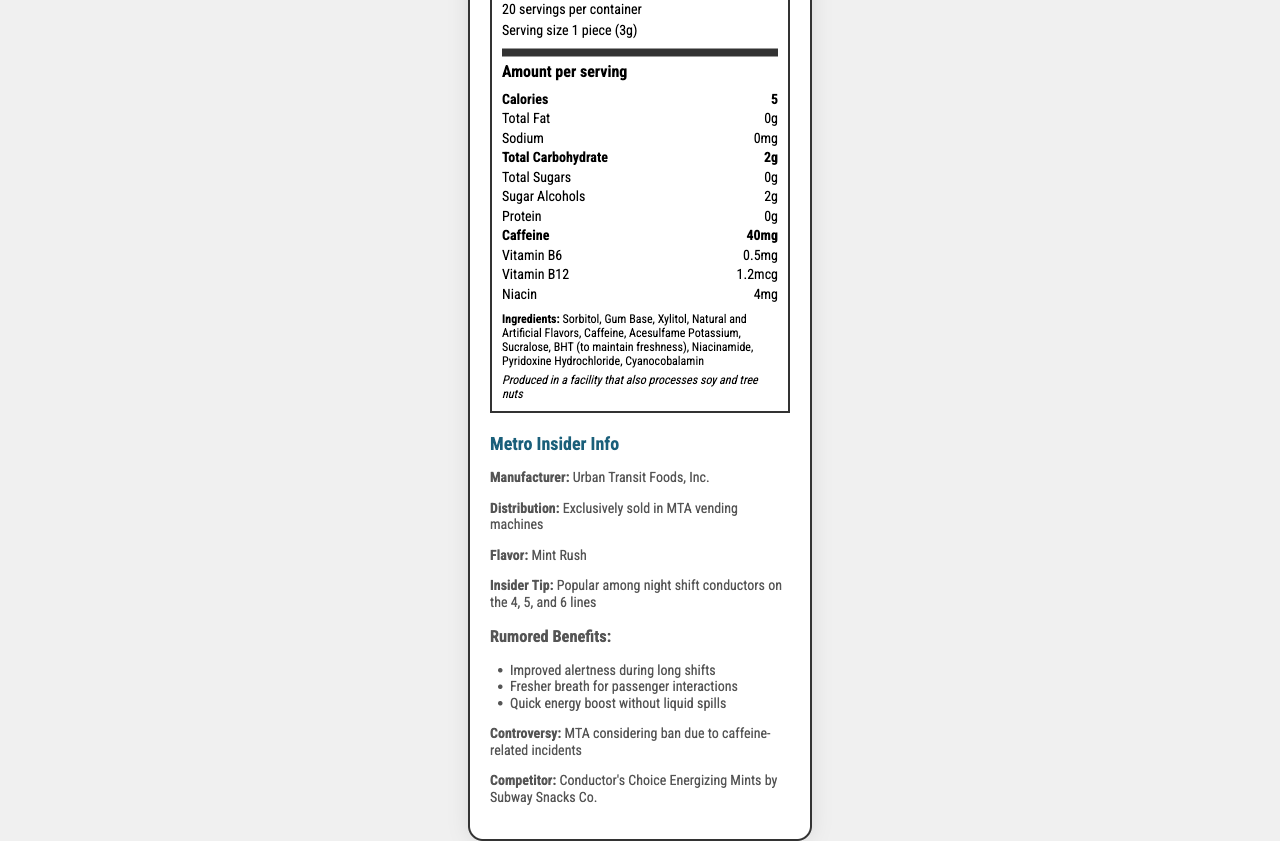how many calories are in one serving of MetroChew Energizing Gum? According to the Nutrition Facts section, each serving of MetroChew Energizing Gum contains 5 calories.
Answer: 5 What is the serving size for MetroChew Energizing Gum? The serving size is listed as 1 piece (3g) in the Nutrition Facts section.
Answer: 1 piece (3g) How many servings are there per container of MetroChew Energizing Gum? The Nutrition Facts section indicates that there are 20 servings per container.
Answer: 20 Which ingredient is used to maintain freshness? The ingredients list includes BHT (to maintain freshness).
Answer: BHT What is the caffeine content per serving of MetroChew Energizing Gum? The Nutrition Facts section shows that the caffeine content per serving is 40mg.
Answer: 40mg Is MetroChew Energizing Gum produced in a facility that processes tree nuts? (Yes/No) The allergen information states that the gum is produced in a facility that also processes soy and tree nuts.
Answer: Yes Which of the following is NOT listed as an ingredient in MetroChew Energizing Gum? A. Sucralose B. Aspartame C. Sorbitol D. Xylitol Aspartame is not listed as an ingredient. Sucralose, Sorbitol, and Xylitol are included.
Answer: B Why might the MTA consider banning MetroChew Energizing Gum? A. Too expensive B. Caffeine-related incidents C. Poor flavor D. Low demand The document mentions that the MTA is considering a ban due to caffeine-related incidents.
Answer: B Which subway lines are mentioned in the insider tip about MetroChew Energizing Gum? The insider tip mentions that the gum is popular among night shift conductors on the 4, 5, and 6 lines.
Answer: 4, 5, and 6 Can MetroChew Energizing Gum be purchased in regular stores? The distribution section notes it is exclusively sold in MTA vending machines.
Answer: No Summarize the main points of the document. The summary captures the essential details about the product, its usage, popularity, nutritional content, and the potential controversy surrounding it.
Answer: MetroChew Energizing Gum is a caffeinated chewing gum designed to improve alertness and provide quick energy boosts. The gum is popular among night shift subway conductors on the 4, 5, and 6 lines. It contains 40mg of caffeine per piece, has 5 calories, and is exclusively sold in MTA vending machines. The product has rumored benefits but faces potential ban considerations due to caffeine-related incidents. What are the three rumored benefits of MetroChew Energizing Gum listed in the document? These benefits are listed under the rumored benefits section in the document.
Answer: Improved alertness during long shifts, Fresher breath for passenger interactions, Quick energy boost without liquid spills Who manufactures MetroChew Energizing Gum? The manufacturer is listed as Urban Transit Foods, Inc. in the Metro Insider Info section.
Answer: Urban Transit Foods, Inc. What flavor is MetroChew Energizing Gum? The Metro Insider Info section states that the flavor is Mint Rush.
Answer: Mint Rush What is the competitor product mentioned in the document? The document lists Conductor's Choice Energizing Mints by Subway Snacks Co. as a competitor.
Answer: Conductor's Choice Energizing Mints by Subway Snacks Co. How much Vitamin B6 is in one serving of MetroChew Energizing Gum? The Nutrition Facts section indicates that one serving contains 0.5mg of Vitamin B6.
Answer: 0.5mg Does MetroChew Energizing Gum contain any protein? The Nutrition Facts section lists the protein content as 0g.
Answer: No What is the percentage daily value of Vitamin B12 in MetroChew Energizing Gum? While the exact percentage is not provided in the data, the presence of 1.2mcg of Vitamin B12 in MetroChew Energizing Gum typically represents about 50% of the daily value based on a typical 2.4mcg daily recommendation. However, this should be clarified with exact data.
Answer: 20% What is the primary reason night shift conductors use MetroChew Energizing Gum? According to the rumored benefits, improved alertness is a key reason night shift conductors use the gum.
Answer: Improved alertness during long shifts What are the total carbohydrates per serving in MetroChew Energizing Gum? The Nutrition Facts section lists the total carbohydrates as 2g per serving.
Answer: 2g Why is MetroChew Energizing Gum controversial? The controversy section mentions that the MTA is considering a ban due to caffeine-related incidents.
Answer: Caffeine-related incidents What vitamins are included in MetroChew Energizing Gum? The Nutrition Facts lists Vitamin B6, Vitamin B12, and Niacin as included vitamins.
Answer: Vitamin B6, Vitamin B12, Niacin 